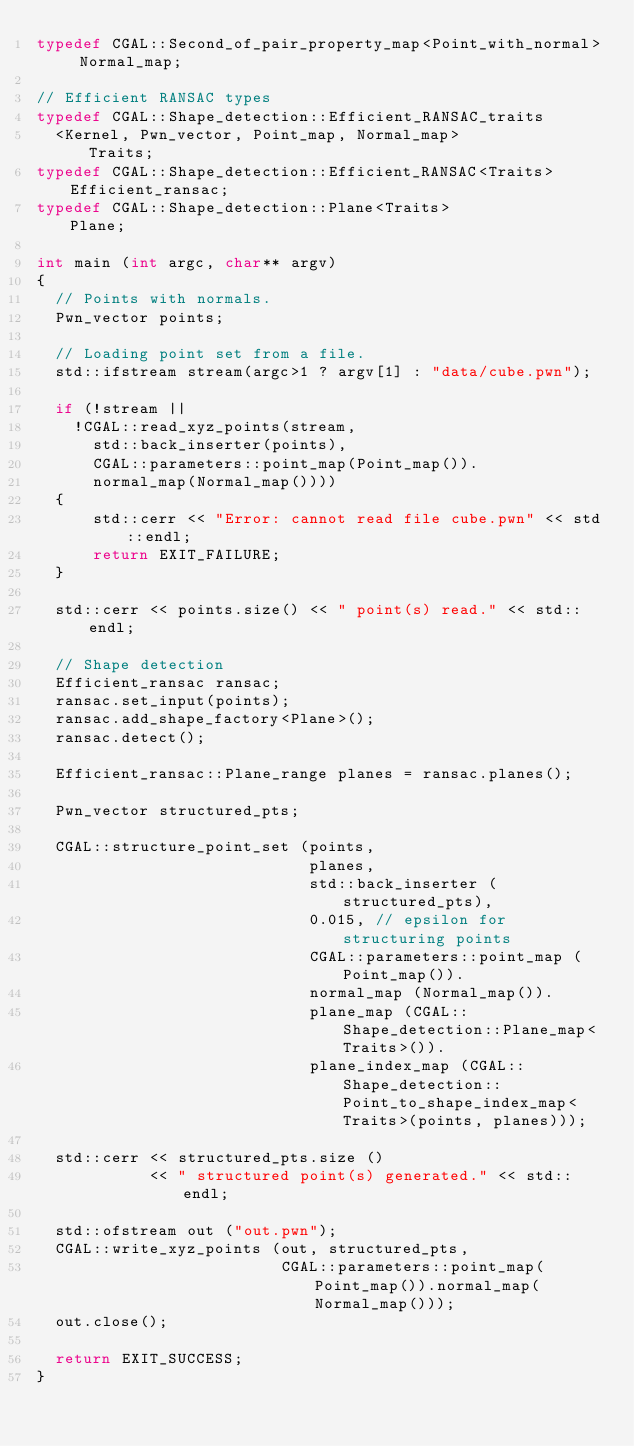Convert code to text. <code><loc_0><loc_0><loc_500><loc_500><_C++_>typedef CGAL::Second_of_pair_property_map<Point_with_normal> Normal_map;

// Efficient RANSAC types
typedef CGAL::Shape_detection::Efficient_RANSAC_traits
  <Kernel, Pwn_vector, Point_map, Normal_map>              Traits;
typedef CGAL::Shape_detection::Efficient_RANSAC<Traits>    Efficient_ransac;
typedef CGAL::Shape_detection::Plane<Traits>               Plane;

int main (int argc, char** argv)
{
  // Points with normals.
  Pwn_vector points;

  // Loading point set from a file. 
  std::ifstream stream(argc>1 ? argv[1] : "data/cube.pwn");

  if (!stream || 
    !CGAL::read_xyz_points(stream,
      std::back_inserter(points),
      CGAL::parameters::point_map(Point_map()).
      normal_map(Normal_map())))
  {
      std::cerr << "Error: cannot read file cube.pwn" << std::endl;
      return EXIT_FAILURE;
  }

  std::cerr << points.size() << " point(s) read." << std::endl;
  
  // Shape detection
  Efficient_ransac ransac;
  ransac.set_input(points);
  ransac.add_shape_factory<Plane>();
  ransac.detect();
  
  Efficient_ransac::Plane_range planes = ransac.planes();
  
  Pwn_vector structured_pts;

  CGAL::structure_point_set (points,
                             planes,
                             std::back_inserter (structured_pts),
                             0.015, // epsilon for structuring points
                             CGAL::parameters::point_map (Point_map()).
                             normal_map (Normal_map()).
                             plane_map (CGAL::Shape_detection::Plane_map<Traits>()).
                             plane_index_map (CGAL::Shape_detection::Point_to_shape_index_map<Traits>(points, planes)));

  std::cerr << structured_pts.size ()
            << " structured point(s) generated." << std::endl;

  std::ofstream out ("out.pwn");
  CGAL::write_xyz_points (out, structured_pts,
                          CGAL::parameters::point_map(Point_map()).normal_map(Normal_map()));
  out.close();
  
  return EXIT_SUCCESS;
}
</code> 